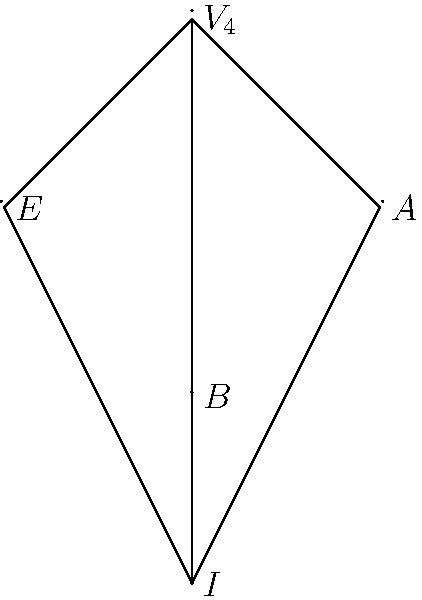In the lattice diagram of subgroups for the Klein four-group $V_4$, how many subgroups of order 2 are there, and what do they represent in terms of Delaney Blaylock's playing style on the basketball court? Let's approach this step-by-step:

1) First, we need to identify the subgroups of order 2 in the Klein four-group lattice diagram:
   - There are three subgroups of order 2: $E$, $A$, and $B$.

2) In group theory, subgroups of order 2 are cyclic groups with two elements.

3) Now, let's relate this to Delaney Blaylock's playing style:
   - Blaylock is known for his versatile play on both offense and defense.
   - We can think of these three subgroups as representing three key aspects of his game:
     a) $E$ could represent his excellent three-point shooting.
     b) $A$ could symbolize his ability to assist teammates.
     c) $B$ might stand for his skills in blocking shots.

4) Just as these subgroups are fundamental to the structure of the Klein four-group, these skills are fundamental to Blaylock's playing style.

5) The fact that there are three such subgroups aligns well with Blaylock's well-rounded game, showcasing his ability to impact the game in multiple ways.
Answer: 3 subgroups (representing Blaylock's 3-point shooting, assists, and blocks) 